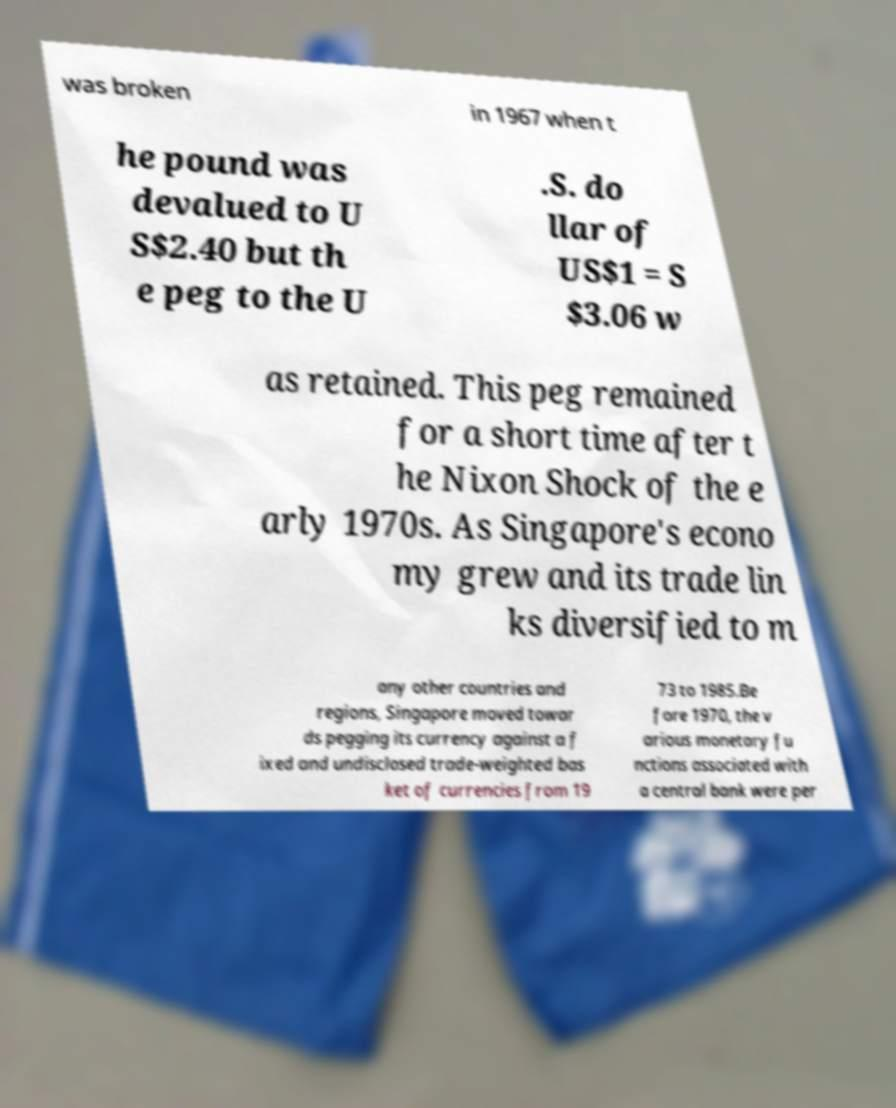Could you assist in decoding the text presented in this image and type it out clearly? was broken in 1967 when t he pound was devalued to U S$2.40 but th e peg to the U .S. do llar of US$1 = S $3.06 w as retained. This peg remained for a short time after t he Nixon Shock of the e arly 1970s. As Singapore's econo my grew and its trade lin ks diversified to m any other countries and regions, Singapore moved towar ds pegging its currency against a f ixed and undisclosed trade-weighted bas ket of currencies from 19 73 to 1985.Be fore 1970, the v arious monetary fu nctions associated with a central bank were per 